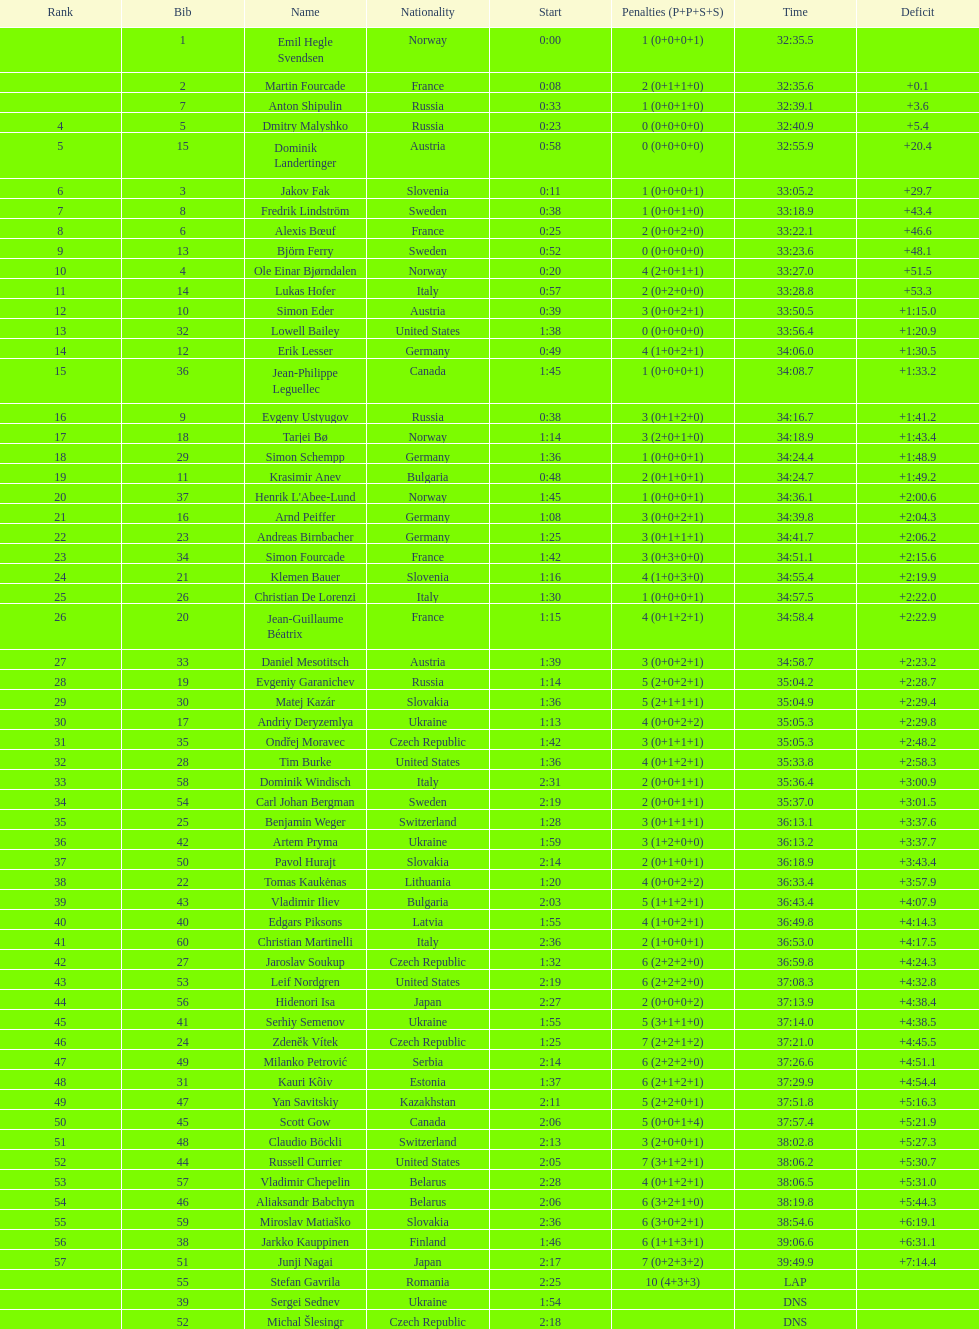How many penalties did germany get all together? 11. Could you help me parse every detail presented in this table? {'header': ['Rank', 'Bib', 'Name', 'Nationality', 'Start', 'Penalties (P+P+S+S)', 'Time', 'Deficit'], 'rows': [['', '1', 'Emil Hegle Svendsen', 'Norway', '0:00', '1 (0+0+0+1)', '32:35.5', ''], ['', '2', 'Martin Fourcade', 'France', '0:08', '2 (0+1+1+0)', '32:35.6', '+0.1'], ['', '7', 'Anton Shipulin', 'Russia', '0:33', '1 (0+0+1+0)', '32:39.1', '+3.6'], ['4', '5', 'Dmitry Malyshko', 'Russia', '0:23', '0 (0+0+0+0)', '32:40.9', '+5.4'], ['5', '15', 'Dominik Landertinger', 'Austria', '0:58', '0 (0+0+0+0)', '32:55.9', '+20.4'], ['6', '3', 'Jakov Fak', 'Slovenia', '0:11', '1 (0+0+0+1)', '33:05.2', '+29.7'], ['7', '8', 'Fredrik Lindström', 'Sweden', '0:38', '1 (0+0+1+0)', '33:18.9', '+43.4'], ['8', '6', 'Alexis Bœuf', 'France', '0:25', '2 (0+0+2+0)', '33:22.1', '+46.6'], ['9', '13', 'Björn Ferry', 'Sweden', '0:52', '0 (0+0+0+0)', '33:23.6', '+48.1'], ['10', '4', 'Ole Einar Bjørndalen', 'Norway', '0:20', '4 (2+0+1+1)', '33:27.0', '+51.5'], ['11', '14', 'Lukas Hofer', 'Italy', '0:57', '2 (0+2+0+0)', '33:28.8', '+53.3'], ['12', '10', 'Simon Eder', 'Austria', '0:39', '3 (0+0+2+1)', '33:50.5', '+1:15.0'], ['13', '32', 'Lowell Bailey', 'United States', '1:38', '0 (0+0+0+0)', '33:56.4', '+1:20.9'], ['14', '12', 'Erik Lesser', 'Germany', '0:49', '4 (1+0+2+1)', '34:06.0', '+1:30.5'], ['15', '36', 'Jean-Philippe Leguellec', 'Canada', '1:45', '1 (0+0+0+1)', '34:08.7', '+1:33.2'], ['16', '9', 'Evgeny Ustyugov', 'Russia', '0:38', '3 (0+1+2+0)', '34:16.7', '+1:41.2'], ['17', '18', 'Tarjei Bø', 'Norway', '1:14', '3 (2+0+1+0)', '34:18.9', '+1:43.4'], ['18', '29', 'Simon Schempp', 'Germany', '1:36', '1 (0+0+0+1)', '34:24.4', '+1:48.9'], ['19', '11', 'Krasimir Anev', 'Bulgaria', '0:48', '2 (0+1+0+1)', '34:24.7', '+1:49.2'], ['20', '37', "Henrik L'Abee-Lund", 'Norway', '1:45', '1 (0+0+0+1)', '34:36.1', '+2:00.6'], ['21', '16', 'Arnd Peiffer', 'Germany', '1:08', '3 (0+0+2+1)', '34:39.8', '+2:04.3'], ['22', '23', 'Andreas Birnbacher', 'Germany', '1:25', '3 (0+1+1+1)', '34:41.7', '+2:06.2'], ['23', '34', 'Simon Fourcade', 'France', '1:42', '3 (0+3+0+0)', '34:51.1', '+2:15.6'], ['24', '21', 'Klemen Bauer', 'Slovenia', '1:16', '4 (1+0+3+0)', '34:55.4', '+2:19.9'], ['25', '26', 'Christian De Lorenzi', 'Italy', '1:30', '1 (0+0+0+1)', '34:57.5', '+2:22.0'], ['26', '20', 'Jean-Guillaume Béatrix', 'France', '1:15', '4 (0+1+2+1)', '34:58.4', '+2:22.9'], ['27', '33', 'Daniel Mesotitsch', 'Austria', '1:39', '3 (0+0+2+1)', '34:58.7', '+2:23.2'], ['28', '19', 'Evgeniy Garanichev', 'Russia', '1:14', '5 (2+0+2+1)', '35:04.2', '+2:28.7'], ['29', '30', 'Matej Kazár', 'Slovakia', '1:36', '5 (2+1+1+1)', '35:04.9', '+2:29.4'], ['30', '17', 'Andriy Deryzemlya', 'Ukraine', '1:13', '4 (0+0+2+2)', '35:05.3', '+2:29.8'], ['31', '35', 'Ondřej Moravec', 'Czech Republic', '1:42', '3 (0+1+1+1)', '35:05.3', '+2:48.2'], ['32', '28', 'Tim Burke', 'United States', '1:36', '4 (0+1+2+1)', '35:33.8', '+2:58.3'], ['33', '58', 'Dominik Windisch', 'Italy', '2:31', '2 (0+0+1+1)', '35:36.4', '+3:00.9'], ['34', '54', 'Carl Johan Bergman', 'Sweden', '2:19', '2 (0+0+1+1)', '35:37.0', '+3:01.5'], ['35', '25', 'Benjamin Weger', 'Switzerland', '1:28', '3 (0+1+1+1)', '36:13.1', '+3:37.6'], ['36', '42', 'Artem Pryma', 'Ukraine', '1:59', '3 (1+2+0+0)', '36:13.2', '+3:37.7'], ['37', '50', 'Pavol Hurajt', 'Slovakia', '2:14', '2 (0+1+0+1)', '36:18.9', '+3:43.4'], ['38', '22', 'Tomas Kaukėnas', 'Lithuania', '1:20', '4 (0+0+2+2)', '36:33.4', '+3:57.9'], ['39', '43', 'Vladimir Iliev', 'Bulgaria', '2:03', '5 (1+1+2+1)', '36:43.4', '+4:07.9'], ['40', '40', 'Edgars Piksons', 'Latvia', '1:55', '4 (1+0+2+1)', '36:49.8', '+4:14.3'], ['41', '60', 'Christian Martinelli', 'Italy', '2:36', '2 (1+0+0+1)', '36:53.0', '+4:17.5'], ['42', '27', 'Jaroslav Soukup', 'Czech Republic', '1:32', '6 (2+2+2+0)', '36:59.8', '+4:24.3'], ['43', '53', 'Leif Nordgren', 'United States', '2:19', '6 (2+2+2+0)', '37:08.3', '+4:32.8'], ['44', '56', 'Hidenori Isa', 'Japan', '2:27', '2 (0+0+0+2)', '37:13.9', '+4:38.4'], ['45', '41', 'Serhiy Semenov', 'Ukraine', '1:55', '5 (3+1+1+0)', '37:14.0', '+4:38.5'], ['46', '24', 'Zdeněk Vítek', 'Czech Republic', '1:25', '7 (2+2+1+2)', '37:21.0', '+4:45.5'], ['47', '49', 'Milanko Petrović', 'Serbia', '2:14', '6 (2+2+2+0)', '37:26.6', '+4:51.1'], ['48', '31', 'Kauri Kõiv', 'Estonia', '1:37', '6 (2+1+2+1)', '37:29.9', '+4:54.4'], ['49', '47', 'Yan Savitskiy', 'Kazakhstan', '2:11', '5 (2+2+0+1)', '37:51.8', '+5:16.3'], ['50', '45', 'Scott Gow', 'Canada', '2:06', '5 (0+0+1+4)', '37:57.4', '+5:21.9'], ['51', '48', 'Claudio Böckli', 'Switzerland', '2:13', '3 (2+0+0+1)', '38:02.8', '+5:27.3'], ['52', '44', 'Russell Currier', 'United States', '2:05', '7 (3+1+2+1)', '38:06.2', '+5:30.7'], ['53', '57', 'Vladimir Chepelin', 'Belarus', '2:28', '4 (0+1+2+1)', '38:06.5', '+5:31.0'], ['54', '46', 'Aliaksandr Babchyn', 'Belarus', '2:06', '6 (3+2+1+0)', '38:19.8', '+5:44.3'], ['55', '59', 'Miroslav Matiaško', 'Slovakia', '2:36', '6 (3+0+2+1)', '38:54.6', '+6:19.1'], ['56', '38', 'Jarkko Kauppinen', 'Finland', '1:46', '6 (1+1+3+1)', '39:06.6', '+6:31.1'], ['57', '51', 'Junji Nagai', 'Japan', '2:17', '7 (0+2+3+2)', '39:49.9', '+7:14.4'], ['', '55', 'Stefan Gavrila', 'Romania', '2:25', '10 (4+3+3)', 'LAP', ''], ['', '39', 'Sergei Sednev', 'Ukraine', '1:54', '', 'DNS', ''], ['', '52', 'Michal Šlesingr', 'Czech Republic', '2:18', '', 'DNS', '']]} 